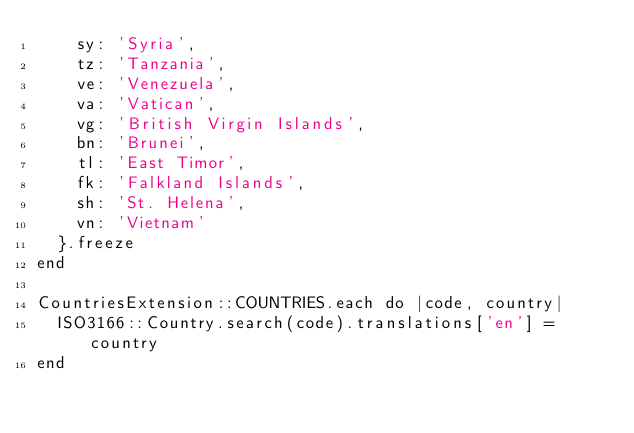<code> <loc_0><loc_0><loc_500><loc_500><_Ruby_>    sy: 'Syria',
    tz: 'Tanzania',
    ve: 'Venezuela',
    va: 'Vatican',
    vg: 'British Virgin Islands',
    bn: 'Brunei',
    tl: 'East Timor',
    fk: 'Falkland Islands',
    sh: 'St. Helena',
    vn: 'Vietnam'
  }.freeze
end

CountriesExtension::COUNTRIES.each do |code, country|
  ISO3166::Country.search(code).translations['en'] = country
end
</code> 